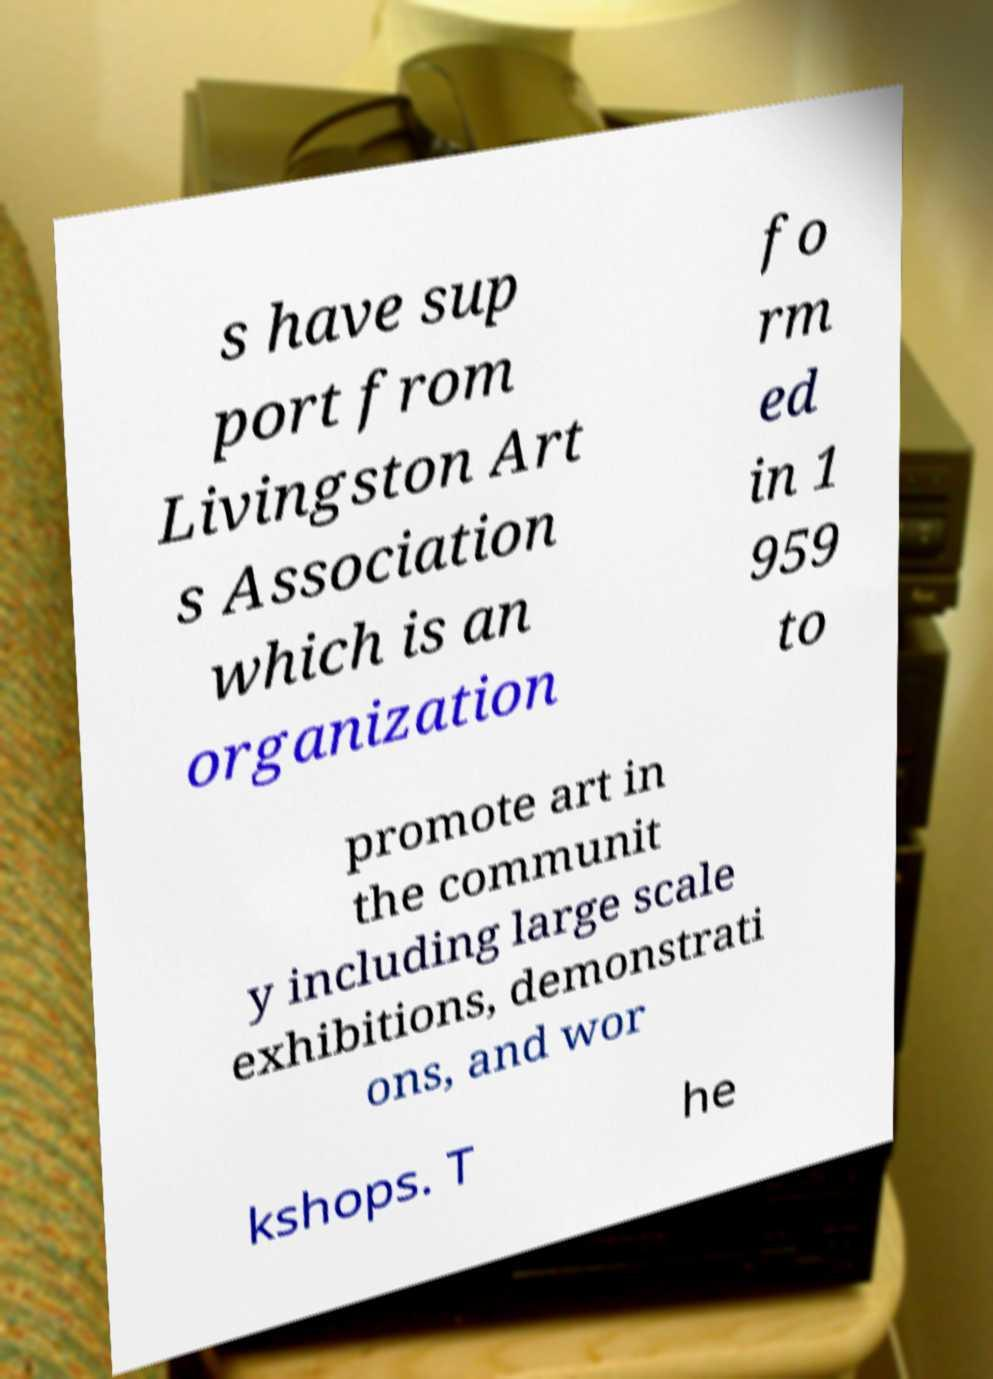What messages or text are displayed in this image? I need them in a readable, typed format. s have sup port from Livingston Art s Association which is an organization fo rm ed in 1 959 to promote art in the communit y including large scale exhibitions, demonstrati ons, and wor kshops. T he 